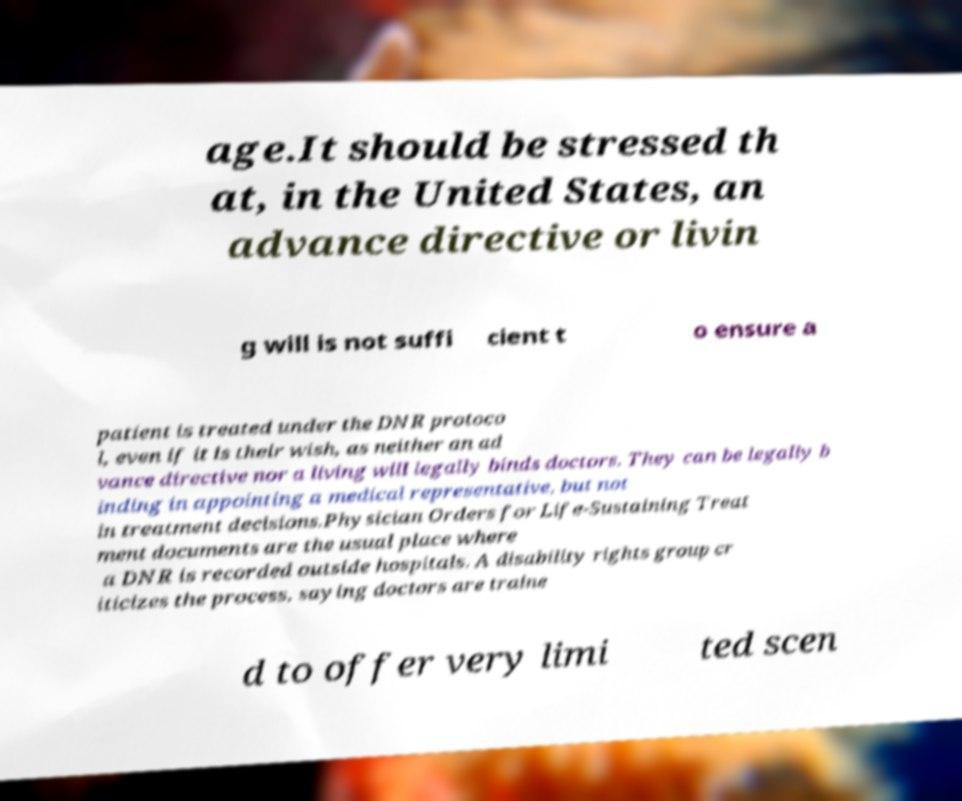Please read and relay the text visible in this image. What does it say? age.It should be stressed th at, in the United States, an advance directive or livin g will is not suffi cient t o ensure a patient is treated under the DNR protoco l, even if it is their wish, as neither an ad vance directive nor a living will legally binds doctors. They can be legally b inding in appointing a medical representative, but not in treatment decisions.Physician Orders for Life-Sustaining Treat ment documents are the usual place where a DNR is recorded outside hospitals. A disability rights group cr iticizes the process, saying doctors are traine d to offer very limi ted scen 